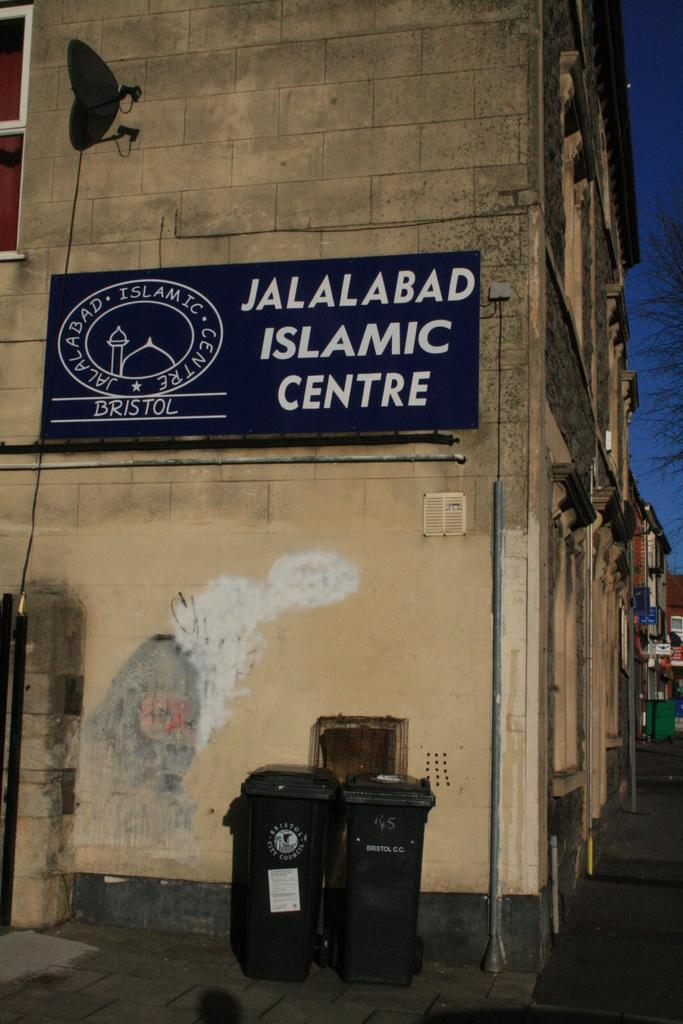<image>
Provide a brief description of the given image. Blue sign which says "Jalalabad Islamic Centre" on a building. 